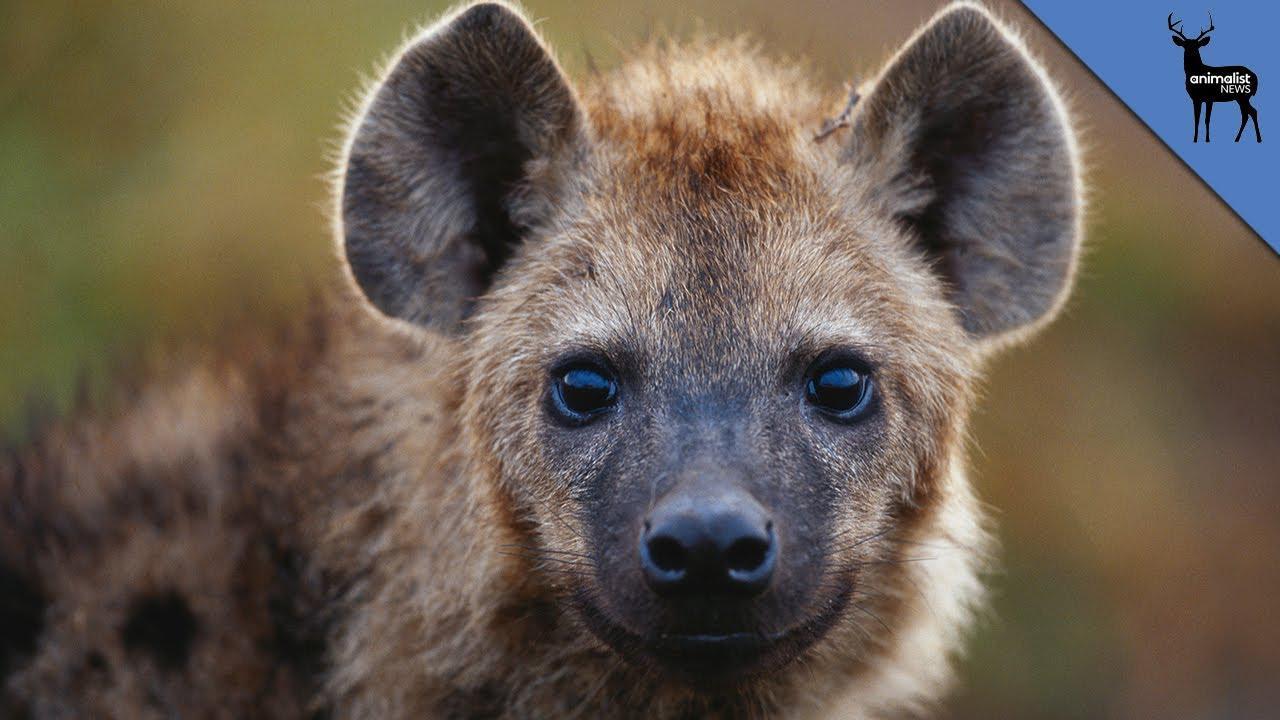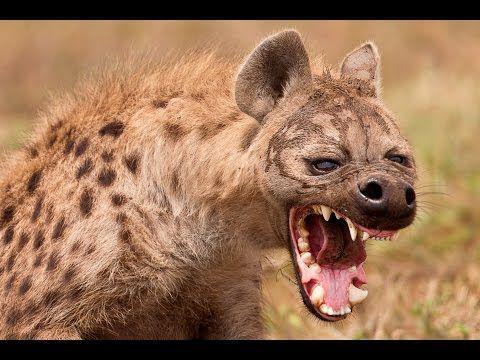The first image is the image on the left, the second image is the image on the right. For the images shown, is this caption "Out of the two animals, one of them has its mouth wide open." true? Answer yes or no. Yes. The first image is the image on the left, the second image is the image on the right. Examine the images to the left and right. Is the description "Right image shows exactly one hyena, which is baring its fangs." accurate? Answer yes or no. Yes. 